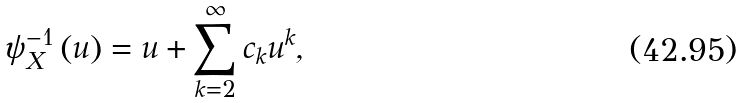<formula> <loc_0><loc_0><loc_500><loc_500>\psi _ { X } ^ { - 1 } \left ( u \right ) = u + \sum _ { k = 2 } ^ { \infty } c _ { k } u ^ { k } ,</formula> 